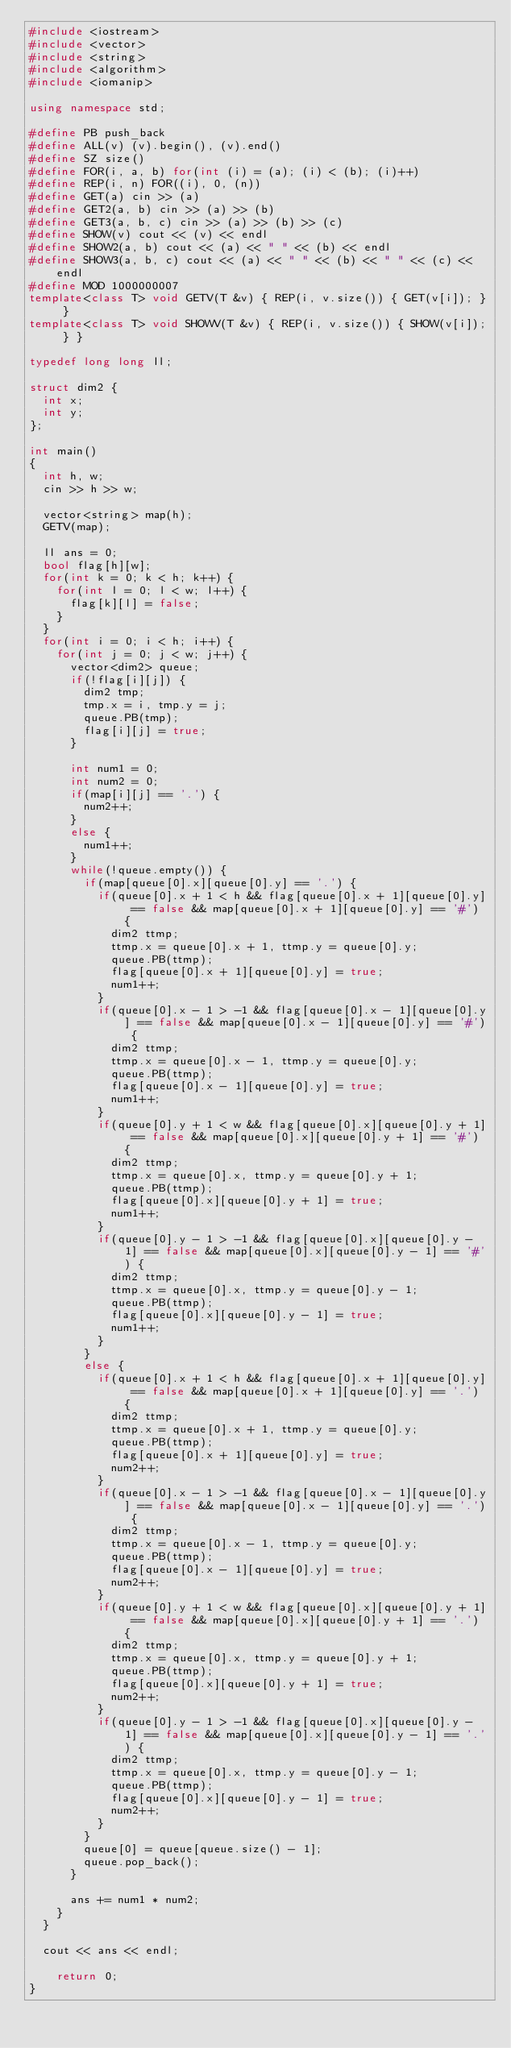Convert code to text. <code><loc_0><loc_0><loc_500><loc_500><_C++_>#include <iostream>
#include <vector>
#include <string>
#include <algorithm>
#include <iomanip>

using namespace std;

#define PB push_back
#define ALL(v) (v).begin(), (v).end()
#define SZ size()
#define FOR(i, a, b) for(int (i) = (a); (i) < (b); (i)++)
#define REP(i, n) FOR((i), 0, (n))
#define GET(a) cin >> (a)
#define GET2(a, b) cin >> (a) >> (b)
#define GET3(a, b, c) cin >> (a) >> (b) >> (c)
#define SHOW(v) cout << (v) << endl
#define SHOW2(a, b) cout << (a) << " " << (b) << endl
#define SHOW3(a, b, c) cout << (a) << " " << (b) << " " << (c) << endl
#define MOD 1000000007
template<class T> void GETV(T &v) { REP(i, v.size()) { GET(v[i]); } }
template<class T> void SHOWV(T &v) { REP(i, v.size()) { SHOW(v[i]); } }

typedef long long ll;

struct dim2 {
	int x;
	int y;
};

int main()
{
	int h, w;
	cin >> h >> w;
	
	vector<string> map(h);
	GETV(map);
	
	ll ans = 0;
	bool flag[h][w];
	for(int k = 0; k < h; k++) {
		for(int l = 0; l < w; l++) {
			flag[k][l] = false;
		}
	}
	for(int i = 0; i < h; i++) {
		for(int j = 0; j < w; j++) {
			vector<dim2> queue;
			if(!flag[i][j]) {
				dim2 tmp;
				tmp.x = i, tmp.y = j;
				queue.PB(tmp);		
				flag[i][j] = true;
			}
			
			int num1 = 0;
			int num2 = 0;
			if(map[i][j] == '.') {
				num2++;
			}
			else {
				num1++;
			}
			while(!queue.empty()) {
				if(map[queue[0].x][queue[0].y] == '.') {
					if(queue[0].x + 1 < h && flag[queue[0].x + 1][queue[0].y] == false && map[queue[0].x + 1][queue[0].y] == '#') {
						dim2 ttmp;
						ttmp.x = queue[0].x + 1, ttmp.y = queue[0].y;
						queue.PB(ttmp);
						flag[queue[0].x + 1][queue[0].y] = true;
						num1++;
					}
					if(queue[0].x - 1 > -1 && flag[queue[0].x - 1][queue[0].y] == false && map[queue[0].x - 1][queue[0].y] == '#') {
						dim2 ttmp;
						ttmp.x = queue[0].x - 1, ttmp.y = queue[0].y;
						queue.PB(ttmp);
						flag[queue[0].x - 1][queue[0].y] = true;
						num1++;
					}
					if(queue[0].y + 1 < w && flag[queue[0].x][queue[0].y + 1] == false && map[queue[0].x][queue[0].y + 1] == '#') {
						dim2 ttmp;
						ttmp.x = queue[0].x, ttmp.y = queue[0].y + 1;
						queue.PB(ttmp);
						flag[queue[0].x][queue[0].y + 1] = true;
						num1++;
					}
					if(queue[0].y - 1 > -1 && flag[queue[0].x][queue[0].y - 1] == false && map[queue[0].x][queue[0].y - 1] == '#') {
						dim2 ttmp;
						ttmp.x = queue[0].x, ttmp.y = queue[0].y - 1;
						queue.PB(ttmp);
						flag[queue[0].x][queue[0].y - 1] = true;
						num1++;
					}
				}
				else {
					if(queue[0].x + 1 < h && flag[queue[0].x + 1][queue[0].y] == false && map[queue[0].x + 1][queue[0].y] == '.') {
						dim2 ttmp;
						ttmp.x = queue[0].x + 1, ttmp.y = queue[0].y;
						queue.PB(ttmp);
						flag[queue[0].x + 1][queue[0].y] = true;
						num2++;
					}
					if(queue[0].x - 1 > -1 && flag[queue[0].x - 1][queue[0].y] == false && map[queue[0].x - 1][queue[0].y] == '.') {
						dim2 ttmp;
						ttmp.x = queue[0].x - 1, ttmp.y = queue[0].y;
						queue.PB(ttmp);
						flag[queue[0].x - 1][queue[0].y] = true;
						num2++;
					}
					if(queue[0].y + 1 < w && flag[queue[0].x][queue[0].y + 1] == false && map[queue[0].x][queue[0].y + 1] == '.') {
						dim2 ttmp;
						ttmp.x = queue[0].x, ttmp.y = queue[0].y + 1;
						queue.PB(ttmp);
						flag[queue[0].x][queue[0].y + 1] = true;
						num2++;
					}
					if(queue[0].y - 1 > -1 && flag[queue[0].x][queue[0].y - 1] == false && map[queue[0].x][queue[0].y - 1] == '.') {
						dim2 ttmp;
						ttmp.x = queue[0].x, ttmp.y = queue[0].y - 1;
						queue.PB(ttmp);
						flag[queue[0].x][queue[0].y - 1] = true;
						num2++;
					}
				}
				queue[0] = queue[queue.size() - 1];
				queue.pop_back();
			}
			
			ans += num1 * num2;
		}
	}
	
	cout << ans << endl;
	
    return 0;
}</code> 